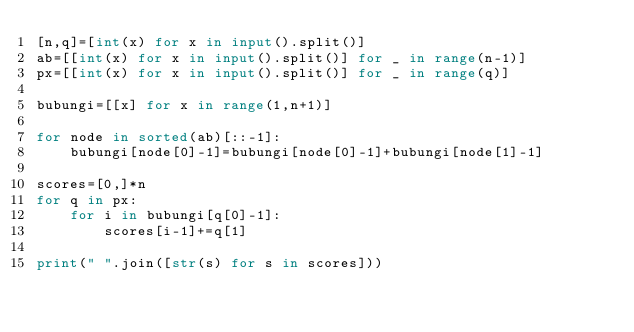Convert code to text. <code><loc_0><loc_0><loc_500><loc_500><_Python_>[n,q]=[int(x) for x in input().split()]
ab=[[int(x) for x in input().split()] for _ in range(n-1)]
px=[[int(x) for x in input().split()] for _ in range(q)]

bubungi=[[x] for x in range(1,n+1)]

for node in sorted(ab)[::-1]:
    bubungi[node[0]-1]=bubungi[node[0]-1]+bubungi[node[1]-1]

scores=[0,]*n
for q in px:
    for i in bubungi[q[0]-1]:
        scores[i-1]+=q[1]

print(" ".join([str(s) for s in scores]))</code> 